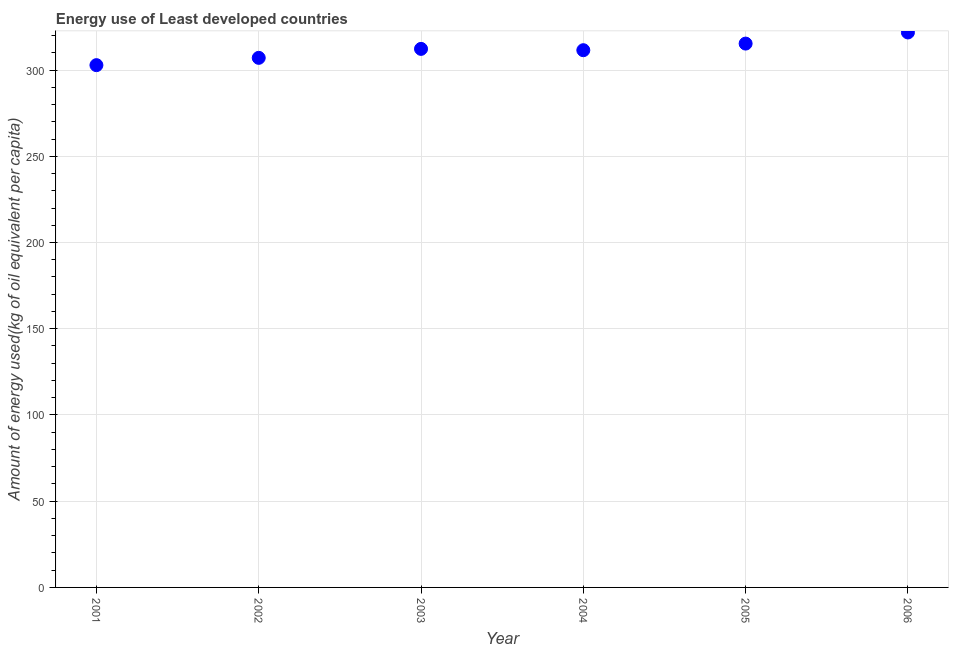What is the amount of energy used in 2002?
Provide a short and direct response. 307.07. Across all years, what is the maximum amount of energy used?
Ensure brevity in your answer.  321.79. Across all years, what is the minimum amount of energy used?
Your answer should be compact. 302.83. In which year was the amount of energy used maximum?
Keep it short and to the point. 2006. In which year was the amount of energy used minimum?
Keep it short and to the point. 2001. What is the sum of the amount of energy used?
Your answer should be compact. 1870.78. What is the difference between the amount of energy used in 2002 and 2005?
Offer a terse response. -8.27. What is the average amount of energy used per year?
Offer a very short reply. 311.8. What is the median amount of energy used?
Ensure brevity in your answer.  311.88. Do a majority of the years between 2005 and 2003 (inclusive) have amount of energy used greater than 210 kg?
Ensure brevity in your answer.  No. What is the ratio of the amount of energy used in 2001 to that in 2003?
Your answer should be compact. 0.97. Is the difference between the amount of energy used in 2004 and 2006 greater than the difference between any two years?
Give a very brief answer. No. What is the difference between the highest and the second highest amount of energy used?
Your answer should be compact. 6.45. Is the sum of the amount of energy used in 2002 and 2006 greater than the maximum amount of energy used across all years?
Make the answer very short. Yes. What is the difference between the highest and the lowest amount of energy used?
Provide a succinct answer. 18.95. How many dotlines are there?
Keep it short and to the point. 1. How many years are there in the graph?
Keep it short and to the point. 6. What is the difference between two consecutive major ticks on the Y-axis?
Offer a terse response. 50. Are the values on the major ticks of Y-axis written in scientific E-notation?
Your answer should be compact. No. Does the graph contain any zero values?
Provide a short and direct response. No. What is the title of the graph?
Provide a short and direct response. Energy use of Least developed countries. What is the label or title of the Y-axis?
Provide a succinct answer. Amount of energy used(kg of oil equivalent per capita). What is the Amount of energy used(kg of oil equivalent per capita) in 2001?
Make the answer very short. 302.83. What is the Amount of energy used(kg of oil equivalent per capita) in 2002?
Make the answer very short. 307.07. What is the Amount of energy used(kg of oil equivalent per capita) in 2003?
Offer a very short reply. 312.26. What is the Amount of energy used(kg of oil equivalent per capita) in 2004?
Offer a terse response. 311.5. What is the Amount of energy used(kg of oil equivalent per capita) in 2005?
Your answer should be very brief. 315.33. What is the Amount of energy used(kg of oil equivalent per capita) in 2006?
Offer a terse response. 321.79. What is the difference between the Amount of energy used(kg of oil equivalent per capita) in 2001 and 2002?
Provide a succinct answer. -4.23. What is the difference between the Amount of energy used(kg of oil equivalent per capita) in 2001 and 2003?
Your response must be concise. -9.43. What is the difference between the Amount of energy used(kg of oil equivalent per capita) in 2001 and 2004?
Keep it short and to the point. -8.67. What is the difference between the Amount of energy used(kg of oil equivalent per capita) in 2001 and 2005?
Your response must be concise. -12.5. What is the difference between the Amount of energy used(kg of oil equivalent per capita) in 2001 and 2006?
Your answer should be compact. -18.95. What is the difference between the Amount of energy used(kg of oil equivalent per capita) in 2002 and 2003?
Your answer should be very brief. -5.2. What is the difference between the Amount of energy used(kg of oil equivalent per capita) in 2002 and 2004?
Your response must be concise. -4.43. What is the difference between the Amount of energy used(kg of oil equivalent per capita) in 2002 and 2005?
Keep it short and to the point. -8.27. What is the difference between the Amount of energy used(kg of oil equivalent per capita) in 2002 and 2006?
Offer a terse response. -14.72. What is the difference between the Amount of energy used(kg of oil equivalent per capita) in 2003 and 2004?
Ensure brevity in your answer.  0.76. What is the difference between the Amount of energy used(kg of oil equivalent per capita) in 2003 and 2005?
Offer a terse response. -3.07. What is the difference between the Amount of energy used(kg of oil equivalent per capita) in 2003 and 2006?
Offer a terse response. -9.52. What is the difference between the Amount of energy used(kg of oil equivalent per capita) in 2004 and 2005?
Your response must be concise. -3.83. What is the difference between the Amount of energy used(kg of oil equivalent per capita) in 2004 and 2006?
Provide a succinct answer. -10.29. What is the difference between the Amount of energy used(kg of oil equivalent per capita) in 2005 and 2006?
Your answer should be very brief. -6.45. What is the ratio of the Amount of energy used(kg of oil equivalent per capita) in 2001 to that in 2004?
Provide a short and direct response. 0.97. What is the ratio of the Amount of energy used(kg of oil equivalent per capita) in 2001 to that in 2005?
Provide a succinct answer. 0.96. What is the ratio of the Amount of energy used(kg of oil equivalent per capita) in 2001 to that in 2006?
Make the answer very short. 0.94. What is the ratio of the Amount of energy used(kg of oil equivalent per capita) in 2002 to that in 2003?
Provide a succinct answer. 0.98. What is the ratio of the Amount of energy used(kg of oil equivalent per capita) in 2002 to that in 2005?
Make the answer very short. 0.97. What is the ratio of the Amount of energy used(kg of oil equivalent per capita) in 2002 to that in 2006?
Offer a terse response. 0.95. What is the ratio of the Amount of energy used(kg of oil equivalent per capita) in 2003 to that in 2005?
Your answer should be compact. 0.99. What is the ratio of the Amount of energy used(kg of oil equivalent per capita) in 2004 to that in 2005?
Ensure brevity in your answer.  0.99. What is the ratio of the Amount of energy used(kg of oil equivalent per capita) in 2004 to that in 2006?
Your answer should be compact. 0.97. 